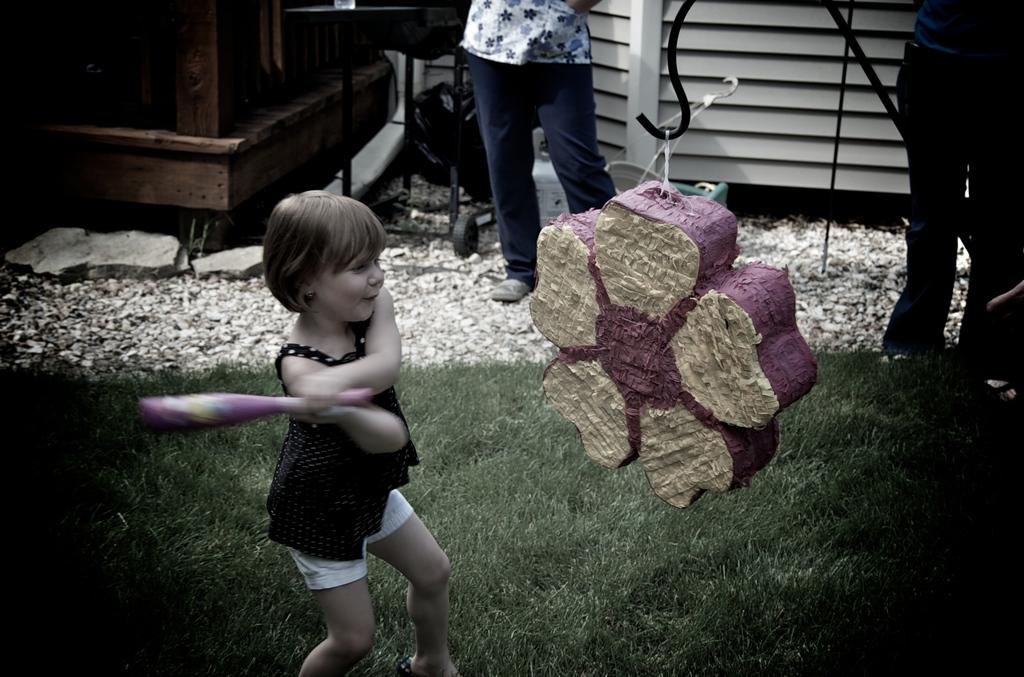Who is the main subject in the image? There is a girl in the image. What is the girl wearing? The girl is wearing a black top. What is the girl trying to do in the image? The girl is trying to hit something. What type of terrain is visible at the bottom of the image? There is grass at the bottom of the image. Can you describe the person standing at the top of the image? There is a person standing at the top of the image, but no specific details are provided about their appearance or actions. What type of cloth is being used to ride the bike in the image? There is no bike present in the image, and therefore no cloth being used to ride it. 